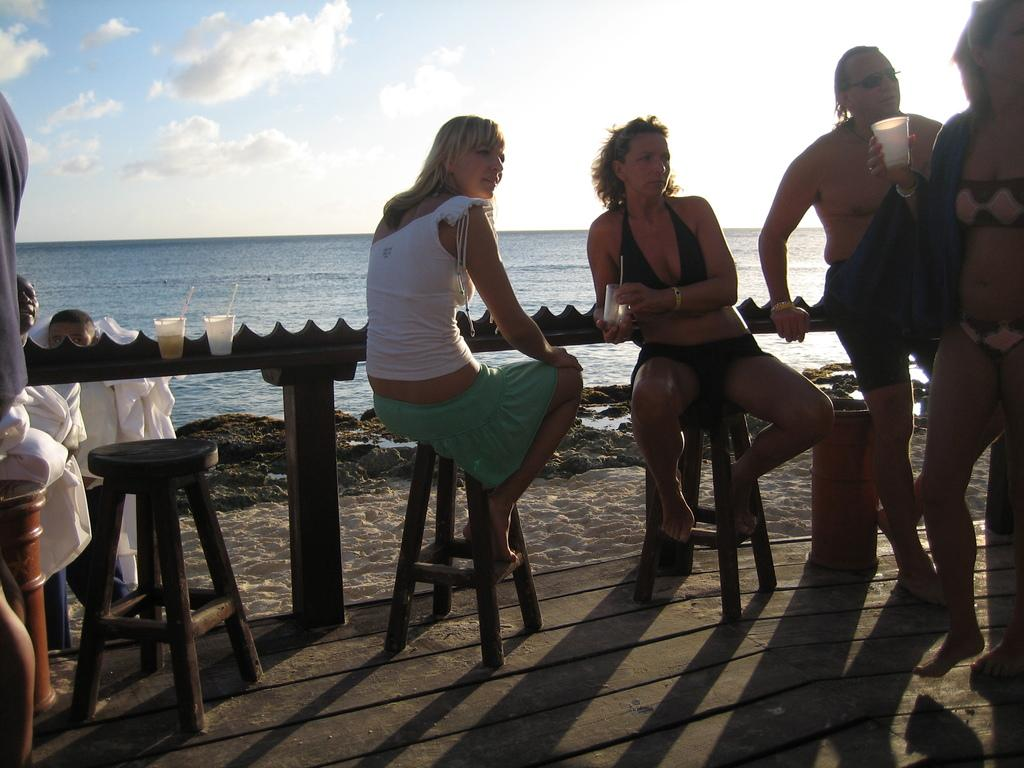What are the people in the image doing? The people in the image are sitting and standing. Where are the people located in the image? The people are at a bridge. What is the location of the bridge in the image? The bridge is near a beach. What are the people holding in the image? The people have coffee cups. What type of table is used to shock the people in the image? There is no table or shocking device present in the image. What is the purpose of the people in the image? The purpose of the people in the image cannot be determined from the provided facts. 